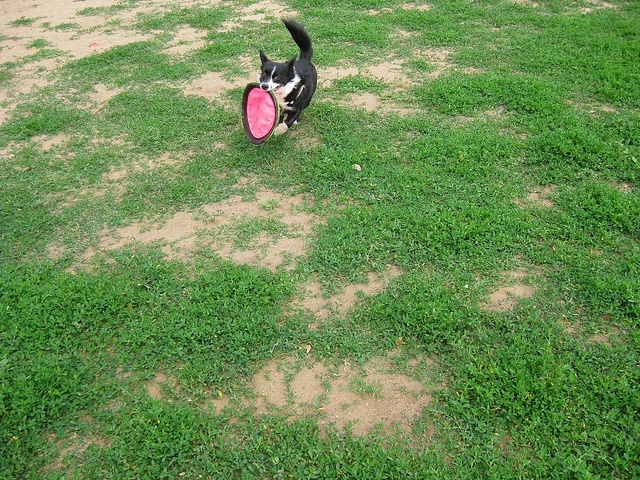Describe the objects in this image and their specific colors. I can see dog in tan, black, gray, white, and darkgray tones and frisbee in tan, lightpink, and gray tones in this image. 